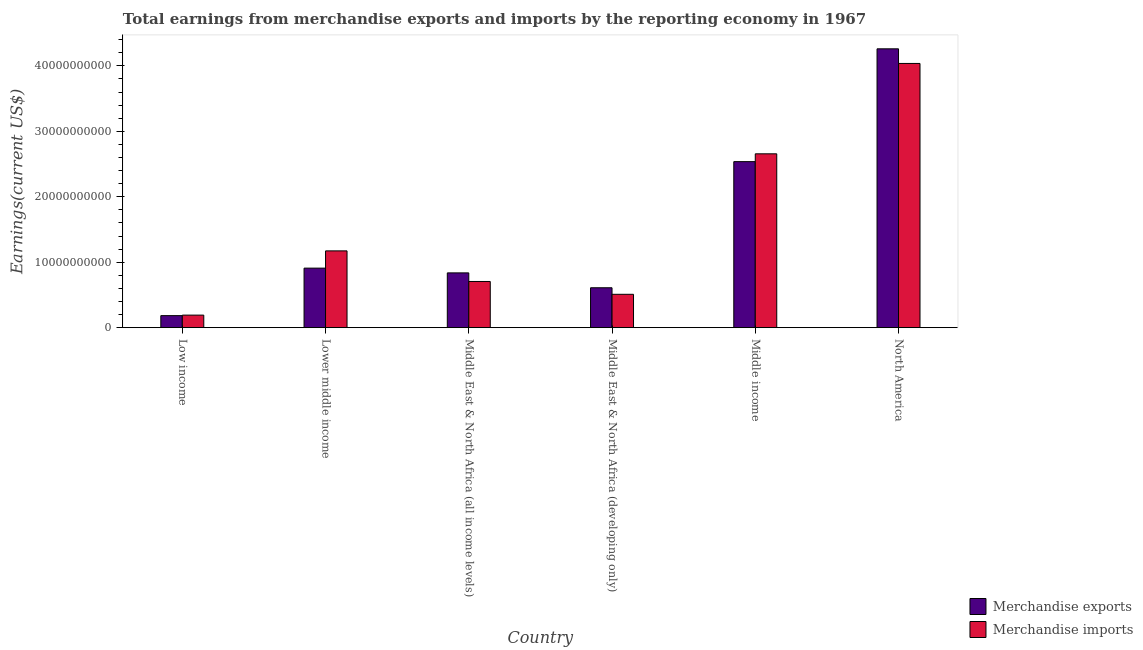How many different coloured bars are there?
Keep it short and to the point. 2. How many groups of bars are there?
Your answer should be very brief. 6. Are the number of bars per tick equal to the number of legend labels?
Provide a succinct answer. Yes. Are the number of bars on each tick of the X-axis equal?
Keep it short and to the point. Yes. How many bars are there on the 3rd tick from the left?
Your answer should be compact. 2. How many bars are there on the 3rd tick from the right?
Ensure brevity in your answer.  2. In how many cases, is the number of bars for a given country not equal to the number of legend labels?
Keep it short and to the point. 0. What is the earnings from merchandise exports in Low income?
Offer a very short reply. 1.84e+09. Across all countries, what is the maximum earnings from merchandise imports?
Offer a very short reply. 4.04e+1. Across all countries, what is the minimum earnings from merchandise imports?
Provide a succinct answer. 1.92e+09. In which country was the earnings from merchandise imports minimum?
Your response must be concise. Low income. What is the total earnings from merchandise exports in the graph?
Your response must be concise. 9.34e+1. What is the difference between the earnings from merchandise exports in Low income and that in Middle East & North Africa (all income levels)?
Ensure brevity in your answer.  -6.53e+09. What is the difference between the earnings from merchandise imports in Lower middle income and the earnings from merchandise exports in Low income?
Your answer should be compact. 9.89e+09. What is the average earnings from merchandise imports per country?
Your answer should be compact. 1.55e+1. What is the difference between the earnings from merchandise imports and earnings from merchandise exports in North America?
Your answer should be compact. -2.23e+09. What is the ratio of the earnings from merchandise imports in Lower middle income to that in Middle East & North Africa (all income levels)?
Make the answer very short. 1.66. Is the earnings from merchandise exports in Low income less than that in Middle income?
Offer a terse response. Yes. What is the difference between the highest and the second highest earnings from merchandise imports?
Offer a terse response. 1.38e+1. What is the difference between the highest and the lowest earnings from merchandise imports?
Your response must be concise. 3.84e+1. In how many countries, is the earnings from merchandise imports greater than the average earnings from merchandise imports taken over all countries?
Keep it short and to the point. 2. What does the 1st bar from the left in Middle East & North Africa (all income levels) represents?
Provide a short and direct response. Merchandise exports. How many countries are there in the graph?
Provide a succinct answer. 6. What is the difference between two consecutive major ticks on the Y-axis?
Ensure brevity in your answer.  1.00e+1. Are the values on the major ticks of Y-axis written in scientific E-notation?
Provide a succinct answer. No. Does the graph contain grids?
Keep it short and to the point. No. Where does the legend appear in the graph?
Offer a very short reply. Bottom right. How many legend labels are there?
Make the answer very short. 2. What is the title of the graph?
Your answer should be compact. Total earnings from merchandise exports and imports by the reporting economy in 1967. What is the label or title of the Y-axis?
Ensure brevity in your answer.  Earnings(current US$). What is the Earnings(current US$) of Merchandise exports in Low income?
Your response must be concise. 1.84e+09. What is the Earnings(current US$) of Merchandise imports in Low income?
Your answer should be very brief. 1.92e+09. What is the Earnings(current US$) in Merchandise exports in Lower middle income?
Provide a succinct answer. 9.10e+09. What is the Earnings(current US$) of Merchandise imports in Lower middle income?
Offer a terse response. 1.17e+1. What is the Earnings(current US$) of Merchandise exports in Middle East & North Africa (all income levels)?
Your answer should be compact. 8.37e+09. What is the Earnings(current US$) of Merchandise imports in Middle East & North Africa (all income levels)?
Keep it short and to the point. 7.06e+09. What is the Earnings(current US$) in Merchandise exports in Middle East & North Africa (developing only)?
Keep it short and to the point. 6.10e+09. What is the Earnings(current US$) in Merchandise imports in Middle East & North Africa (developing only)?
Offer a very short reply. 5.10e+09. What is the Earnings(current US$) of Merchandise exports in Middle income?
Keep it short and to the point. 2.54e+1. What is the Earnings(current US$) in Merchandise imports in Middle income?
Ensure brevity in your answer.  2.66e+1. What is the Earnings(current US$) of Merchandise exports in North America?
Give a very brief answer. 4.26e+1. What is the Earnings(current US$) in Merchandise imports in North America?
Make the answer very short. 4.04e+1. Across all countries, what is the maximum Earnings(current US$) of Merchandise exports?
Keep it short and to the point. 4.26e+1. Across all countries, what is the maximum Earnings(current US$) of Merchandise imports?
Your answer should be compact. 4.04e+1. Across all countries, what is the minimum Earnings(current US$) of Merchandise exports?
Your response must be concise. 1.84e+09. Across all countries, what is the minimum Earnings(current US$) in Merchandise imports?
Keep it short and to the point. 1.92e+09. What is the total Earnings(current US$) of Merchandise exports in the graph?
Make the answer very short. 9.34e+1. What is the total Earnings(current US$) in Merchandise imports in the graph?
Your answer should be very brief. 9.27e+1. What is the difference between the Earnings(current US$) of Merchandise exports in Low income and that in Lower middle income?
Your answer should be very brief. -7.26e+09. What is the difference between the Earnings(current US$) in Merchandise imports in Low income and that in Lower middle income?
Keep it short and to the point. -9.81e+09. What is the difference between the Earnings(current US$) in Merchandise exports in Low income and that in Middle East & North Africa (all income levels)?
Provide a succinct answer. -6.53e+09. What is the difference between the Earnings(current US$) of Merchandise imports in Low income and that in Middle East & North Africa (all income levels)?
Your answer should be compact. -5.14e+09. What is the difference between the Earnings(current US$) of Merchandise exports in Low income and that in Middle East & North Africa (developing only)?
Your answer should be very brief. -4.26e+09. What is the difference between the Earnings(current US$) of Merchandise imports in Low income and that in Middle East & North Africa (developing only)?
Offer a very short reply. -3.18e+09. What is the difference between the Earnings(current US$) in Merchandise exports in Low income and that in Middle income?
Your response must be concise. -2.35e+1. What is the difference between the Earnings(current US$) in Merchandise imports in Low income and that in Middle income?
Offer a terse response. -2.46e+1. What is the difference between the Earnings(current US$) in Merchandise exports in Low income and that in North America?
Your answer should be compact. -4.08e+1. What is the difference between the Earnings(current US$) of Merchandise imports in Low income and that in North America?
Give a very brief answer. -3.84e+1. What is the difference between the Earnings(current US$) in Merchandise exports in Lower middle income and that in Middle East & North Africa (all income levels)?
Provide a succinct answer. 7.27e+08. What is the difference between the Earnings(current US$) of Merchandise imports in Lower middle income and that in Middle East & North Africa (all income levels)?
Your response must be concise. 4.67e+09. What is the difference between the Earnings(current US$) in Merchandise exports in Lower middle income and that in Middle East & North Africa (developing only)?
Ensure brevity in your answer.  3.00e+09. What is the difference between the Earnings(current US$) of Merchandise imports in Lower middle income and that in Middle East & North Africa (developing only)?
Ensure brevity in your answer.  6.63e+09. What is the difference between the Earnings(current US$) in Merchandise exports in Lower middle income and that in Middle income?
Keep it short and to the point. -1.63e+1. What is the difference between the Earnings(current US$) in Merchandise imports in Lower middle income and that in Middle income?
Ensure brevity in your answer.  -1.48e+1. What is the difference between the Earnings(current US$) of Merchandise exports in Lower middle income and that in North America?
Offer a terse response. -3.35e+1. What is the difference between the Earnings(current US$) of Merchandise imports in Lower middle income and that in North America?
Keep it short and to the point. -2.86e+1. What is the difference between the Earnings(current US$) in Merchandise exports in Middle East & North Africa (all income levels) and that in Middle East & North Africa (developing only)?
Make the answer very short. 2.27e+09. What is the difference between the Earnings(current US$) of Merchandise imports in Middle East & North Africa (all income levels) and that in Middle East & North Africa (developing only)?
Provide a succinct answer. 1.96e+09. What is the difference between the Earnings(current US$) of Merchandise exports in Middle East & North Africa (all income levels) and that in Middle income?
Keep it short and to the point. -1.70e+1. What is the difference between the Earnings(current US$) in Merchandise imports in Middle East & North Africa (all income levels) and that in Middle income?
Provide a short and direct response. -1.95e+1. What is the difference between the Earnings(current US$) in Merchandise exports in Middle East & North Africa (all income levels) and that in North America?
Your answer should be very brief. -3.42e+1. What is the difference between the Earnings(current US$) of Merchandise imports in Middle East & North Africa (all income levels) and that in North America?
Your answer should be very brief. -3.33e+1. What is the difference between the Earnings(current US$) of Merchandise exports in Middle East & North Africa (developing only) and that in Middle income?
Offer a very short reply. -1.93e+1. What is the difference between the Earnings(current US$) in Merchandise imports in Middle East & North Africa (developing only) and that in Middle income?
Provide a short and direct response. -2.15e+1. What is the difference between the Earnings(current US$) of Merchandise exports in Middle East & North Africa (developing only) and that in North America?
Offer a terse response. -3.65e+1. What is the difference between the Earnings(current US$) of Merchandise imports in Middle East & North Africa (developing only) and that in North America?
Keep it short and to the point. -3.53e+1. What is the difference between the Earnings(current US$) in Merchandise exports in Middle income and that in North America?
Offer a terse response. -1.72e+1. What is the difference between the Earnings(current US$) of Merchandise imports in Middle income and that in North America?
Your answer should be compact. -1.38e+1. What is the difference between the Earnings(current US$) in Merchandise exports in Low income and the Earnings(current US$) in Merchandise imports in Lower middle income?
Offer a terse response. -9.89e+09. What is the difference between the Earnings(current US$) in Merchandise exports in Low income and the Earnings(current US$) in Merchandise imports in Middle East & North Africa (all income levels)?
Your answer should be very brief. -5.22e+09. What is the difference between the Earnings(current US$) of Merchandise exports in Low income and the Earnings(current US$) of Merchandise imports in Middle East & North Africa (developing only)?
Your answer should be compact. -3.26e+09. What is the difference between the Earnings(current US$) of Merchandise exports in Low income and the Earnings(current US$) of Merchandise imports in Middle income?
Give a very brief answer. -2.47e+1. What is the difference between the Earnings(current US$) of Merchandise exports in Low income and the Earnings(current US$) of Merchandise imports in North America?
Ensure brevity in your answer.  -3.85e+1. What is the difference between the Earnings(current US$) in Merchandise exports in Lower middle income and the Earnings(current US$) in Merchandise imports in Middle East & North Africa (all income levels)?
Offer a very short reply. 2.04e+09. What is the difference between the Earnings(current US$) of Merchandise exports in Lower middle income and the Earnings(current US$) of Merchandise imports in Middle East & North Africa (developing only)?
Give a very brief answer. 4.00e+09. What is the difference between the Earnings(current US$) in Merchandise exports in Lower middle income and the Earnings(current US$) in Merchandise imports in Middle income?
Keep it short and to the point. -1.75e+1. What is the difference between the Earnings(current US$) of Merchandise exports in Lower middle income and the Earnings(current US$) of Merchandise imports in North America?
Make the answer very short. -3.13e+1. What is the difference between the Earnings(current US$) of Merchandise exports in Middle East & North Africa (all income levels) and the Earnings(current US$) of Merchandise imports in Middle East & North Africa (developing only)?
Provide a succinct answer. 3.27e+09. What is the difference between the Earnings(current US$) in Merchandise exports in Middle East & North Africa (all income levels) and the Earnings(current US$) in Merchandise imports in Middle income?
Give a very brief answer. -1.82e+1. What is the difference between the Earnings(current US$) in Merchandise exports in Middle East & North Africa (all income levels) and the Earnings(current US$) in Merchandise imports in North America?
Offer a terse response. -3.20e+1. What is the difference between the Earnings(current US$) in Merchandise exports in Middle East & North Africa (developing only) and the Earnings(current US$) in Merchandise imports in Middle income?
Ensure brevity in your answer.  -2.05e+1. What is the difference between the Earnings(current US$) in Merchandise exports in Middle East & North Africa (developing only) and the Earnings(current US$) in Merchandise imports in North America?
Provide a succinct answer. -3.43e+1. What is the difference between the Earnings(current US$) of Merchandise exports in Middle income and the Earnings(current US$) of Merchandise imports in North America?
Your answer should be compact. -1.50e+1. What is the average Earnings(current US$) in Merchandise exports per country?
Your answer should be compact. 1.56e+1. What is the average Earnings(current US$) of Merchandise imports per country?
Your response must be concise. 1.55e+1. What is the difference between the Earnings(current US$) in Merchandise exports and Earnings(current US$) in Merchandise imports in Low income?
Offer a very short reply. -7.80e+07. What is the difference between the Earnings(current US$) of Merchandise exports and Earnings(current US$) of Merchandise imports in Lower middle income?
Keep it short and to the point. -2.63e+09. What is the difference between the Earnings(current US$) in Merchandise exports and Earnings(current US$) in Merchandise imports in Middle East & North Africa (all income levels)?
Offer a very short reply. 1.31e+09. What is the difference between the Earnings(current US$) in Merchandise exports and Earnings(current US$) in Merchandise imports in Middle East & North Africa (developing only)?
Provide a short and direct response. 1.00e+09. What is the difference between the Earnings(current US$) in Merchandise exports and Earnings(current US$) in Merchandise imports in Middle income?
Your answer should be very brief. -1.20e+09. What is the difference between the Earnings(current US$) of Merchandise exports and Earnings(current US$) of Merchandise imports in North America?
Keep it short and to the point. 2.23e+09. What is the ratio of the Earnings(current US$) in Merchandise exports in Low income to that in Lower middle income?
Offer a very short reply. 0.2. What is the ratio of the Earnings(current US$) in Merchandise imports in Low income to that in Lower middle income?
Make the answer very short. 0.16. What is the ratio of the Earnings(current US$) of Merchandise exports in Low income to that in Middle East & North Africa (all income levels)?
Your answer should be compact. 0.22. What is the ratio of the Earnings(current US$) in Merchandise imports in Low income to that in Middle East & North Africa (all income levels)?
Give a very brief answer. 0.27. What is the ratio of the Earnings(current US$) of Merchandise exports in Low income to that in Middle East & North Africa (developing only)?
Provide a short and direct response. 0.3. What is the ratio of the Earnings(current US$) of Merchandise imports in Low income to that in Middle East & North Africa (developing only)?
Keep it short and to the point. 0.38. What is the ratio of the Earnings(current US$) in Merchandise exports in Low income to that in Middle income?
Your response must be concise. 0.07. What is the ratio of the Earnings(current US$) in Merchandise imports in Low income to that in Middle income?
Your response must be concise. 0.07. What is the ratio of the Earnings(current US$) in Merchandise exports in Low income to that in North America?
Keep it short and to the point. 0.04. What is the ratio of the Earnings(current US$) of Merchandise imports in Low income to that in North America?
Your answer should be very brief. 0.05. What is the ratio of the Earnings(current US$) in Merchandise exports in Lower middle income to that in Middle East & North Africa (all income levels)?
Offer a terse response. 1.09. What is the ratio of the Earnings(current US$) of Merchandise imports in Lower middle income to that in Middle East & North Africa (all income levels)?
Your answer should be compact. 1.66. What is the ratio of the Earnings(current US$) in Merchandise exports in Lower middle income to that in Middle East & North Africa (developing only)?
Provide a short and direct response. 1.49. What is the ratio of the Earnings(current US$) of Merchandise imports in Lower middle income to that in Middle East & North Africa (developing only)?
Your response must be concise. 2.3. What is the ratio of the Earnings(current US$) of Merchandise exports in Lower middle income to that in Middle income?
Make the answer very short. 0.36. What is the ratio of the Earnings(current US$) in Merchandise imports in Lower middle income to that in Middle income?
Your answer should be very brief. 0.44. What is the ratio of the Earnings(current US$) of Merchandise exports in Lower middle income to that in North America?
Provide a short and direct response. 0.21. What is the ratio of the Earnings(current US$) in Merchandise imports in Lower middle income to that in North America?
Ensure brevity in your answer.  0.29. What is the ratio of the Earnings(current US$) of Merchandise exports in Middle East & North Africa (all income levels) to that in Middle East & North Africa (developing only)?
Offer a very short reply. 1.37. What is the ratio of the Earnings(current US$) in Merchandise imports in Middle East & North Africa (all income levels) to that in Middle East & North Africa (developing only)?
Your answer should be compact. 1.38. What is the ratio of the Earnings(current US$) in Merchandise exports in Middle East & North Africa (all income levels) to that in Middle income?
Provide a succinct answer. 0.33. What is the ratio of the Earnings(current US$) of Merchandise imports in Middle East & North Africa (all income levels) to that in Middle income?
Offer a terse response. 0.27. What is the ratio of the Earnings(current US$) of Merchandise exports in Middle East & North Africa (all income levels) to that in North America?
Ensure brevity in your answer.  0.2. What is the ratio of the Earnings(current US$) of Merchandise imports in Middle East & North Africa (all income levels) to that in North America?
Keep it short and to the point. 0.17. What is the ratio of the Earnings(current US$) of Merchandise exports in Middle East & North Africa (developing only) to that in Middle income?
Your response must be concise. 0.24. What is the ratio of the Earnings(current US$) in Merchandise imports in Middle East & North Africa (developing only) to that in Middle income?
Provide a short and direct response. 0.19. What is the ratio of the Earnings(current US$) in Merchandise exports in Middle East & North Africa (developing only) to that in North America?
Provide a succinct answer. 0.14. What is the ratio of the Earnings(current US$) of Merchandise imports in Middle East & North Africa (developing only) to that in North America?
Your answer should be very brief. 0.13. What is the ratio of the Earnings(current US$) in Merchandise exports in Middle income to that in North America?
Provide a short and direct response. 0.6. What is the ratio of the Earnings(current US$) of Merchandise imports in Middle income to that in North America?
Your answer should be compact. 0.66. What is the difference between the highest and the second highest Earnings(current US$) of Merchandise exports?
Your answer should be compact. 1.72e+1. What is the difference between the highest and the second highest Earnings(current US$) in Merchandise imports?
Give a very brief answer. 1.38e+1. What is the difference between the highest and the lowest Earnings(current US$) of Merchandise exports?
Provide a short and direct response. 4.08e+1. What is the difference between the highest and the lowest Earnings(current US$) of Merchandise imports?
Ensure brevity in your answer.  3.84e+1. 